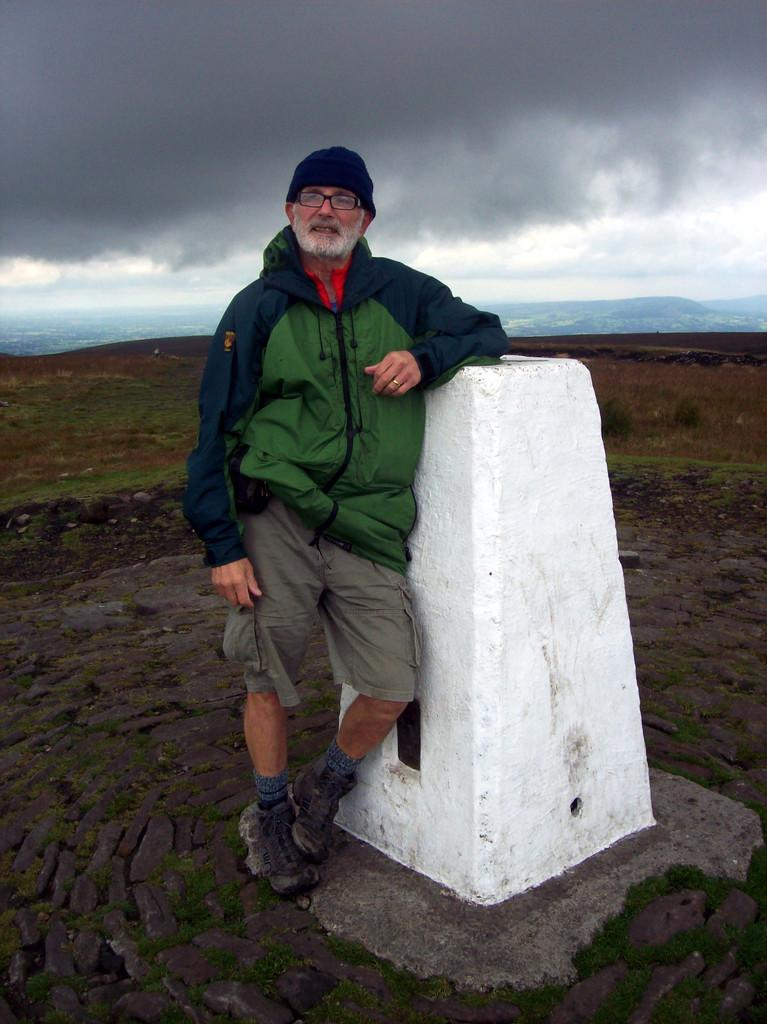What is the main subject in the image? There is a man standing in the image. What structure can be seen in the image? There is a pillar in the image. What type of natural feature is present in the image? There is a hill in the image. What is visible in the background of the image? The sky is visible in the background of the image. What type of story is being told by the pillar in the image? There is no story being told by the pillar in the image; it is a structural element. 